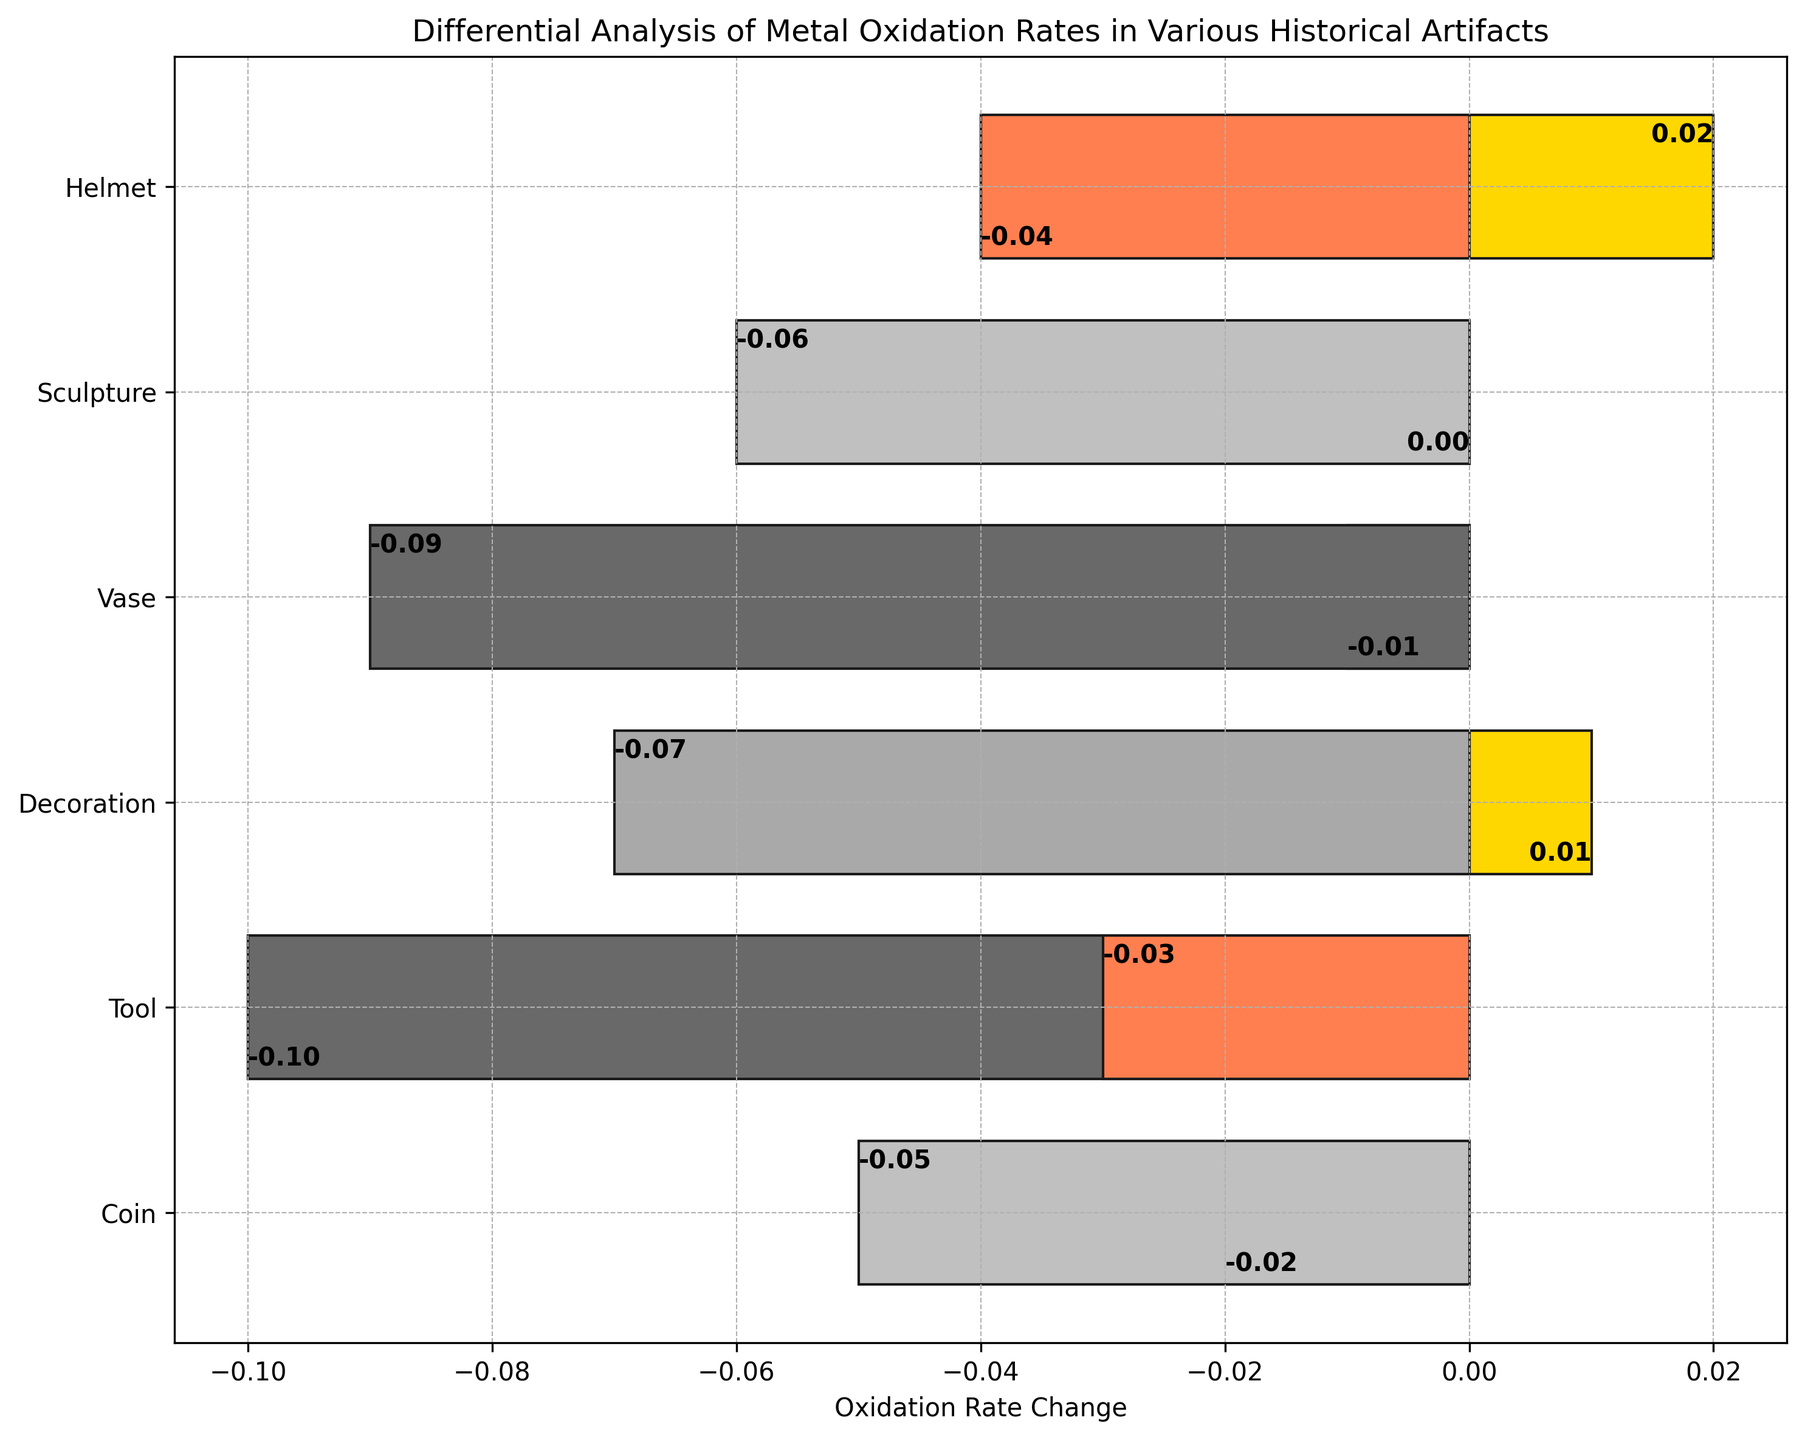What is the oxidation rate change for Iron artifacts? There are two Iron artifacts: a Tool and a Vase. The oxidation rate changes for these artifacts are -0.10 and -0.09, respectively.
Answer: -0.10 and -0.09 Which artifact has the most negative oxidation rate change? By visual inspection, the Tool made of Iron has the most negative oxidation rate change of -0.10.
Answer: Tool (Iron) Which material exhibits both a positive and a negative oxidation rate change across different artifacts? By inspecting the chart, Gold shows both a positive change (Decoration: 0.01 and Helmet: 0.02) and no other materials exhibit this trait.
Answer: Gold What is the difference between the oxidation rates of the Bronze Coin and the Bronze Sculpture? The oxidation rate change for the Bronze Coin is -0.02, and for the Bronze Sculpture, it is 0.00. The difference is 0.00 - (-0.02) which is 0.02.
Answer: 0.02 Compare the oxidation rate change for Silver artifacts. Which artifact has the higher change? The Silver artifacts are a Coin (-0.05) and a Sculpture (-0.06). -0.05 is higher (less negative) than -0.06.
Answer: Coin (Silver) What is the average oxidation rate change for all the listed artifacts? Sum all oxidation rate changes: (-0.02 -0.05 -0.10 -0.03 +0.01 -0.07 -0.01 -0.09 +0.00 -0.06 -0.04 +0.02) = -0.44. There are 12 artifacts, so the average is -0.44/12.
Answer: -0.037 Which artifact has the highest positive oxidation rate change, and what is its material? By visually inspecting the chart, the Helmet made of Gold has the highest positive rate change of 0.02.
Answer: Helmet (Gold) How many artifacts have a positive oxidation rate change? By visually inspecting the chart, two artifacts have positive oxidation rate changes: Decoration (Gold, 0.01) and Helmet (Gold, 0.02).
Answer: 2 Compare the total oxidation rate change for Tool and Vase artifacts. Which has a higher total oxidation rate change? Sum the oxidation rate changes for each artifact type: Tools (Iron: -0.10, Copper: -0.03), total is -0.13. Vases (Ceramic: -0.01, Iron: -0.09), total is -0.10. The Vase has a higher (less negative) total oxidation rate change.
Answer: Vase What material has the most artifacts evaluated for oxidation rate change in this analysis? By counting the unique materials, Iron and Gold each appear in two artifacts, which is the highest count.
Answer: Iron and Gold 